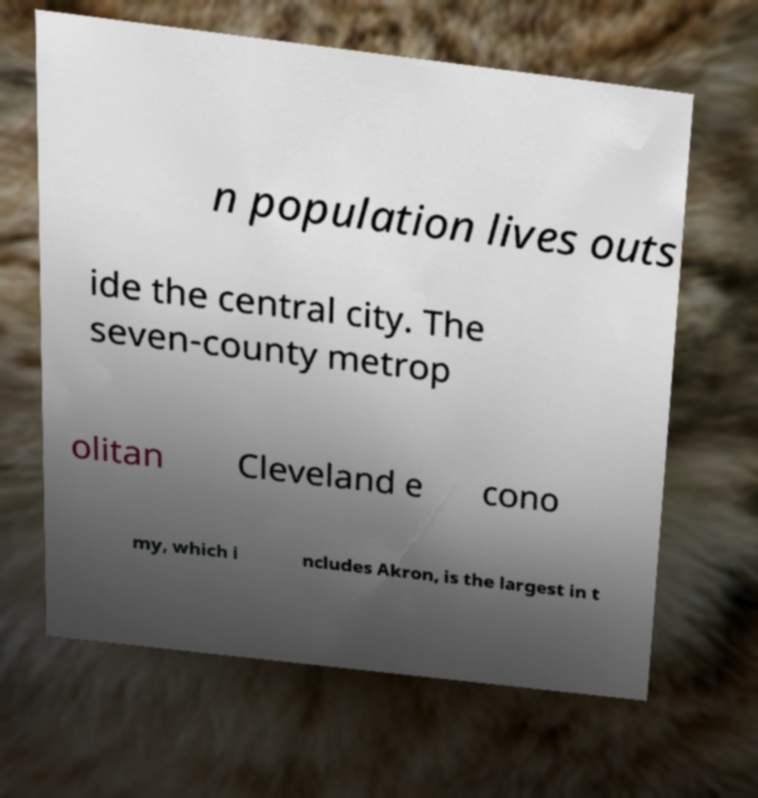There's text embedded in this image that I need extracted. Can you transcribe it verbatim? n population lives outs ide the central city. The seven-county metrop olitan Cleveland e cono my, which i ncludes Akron, is the largest in t 